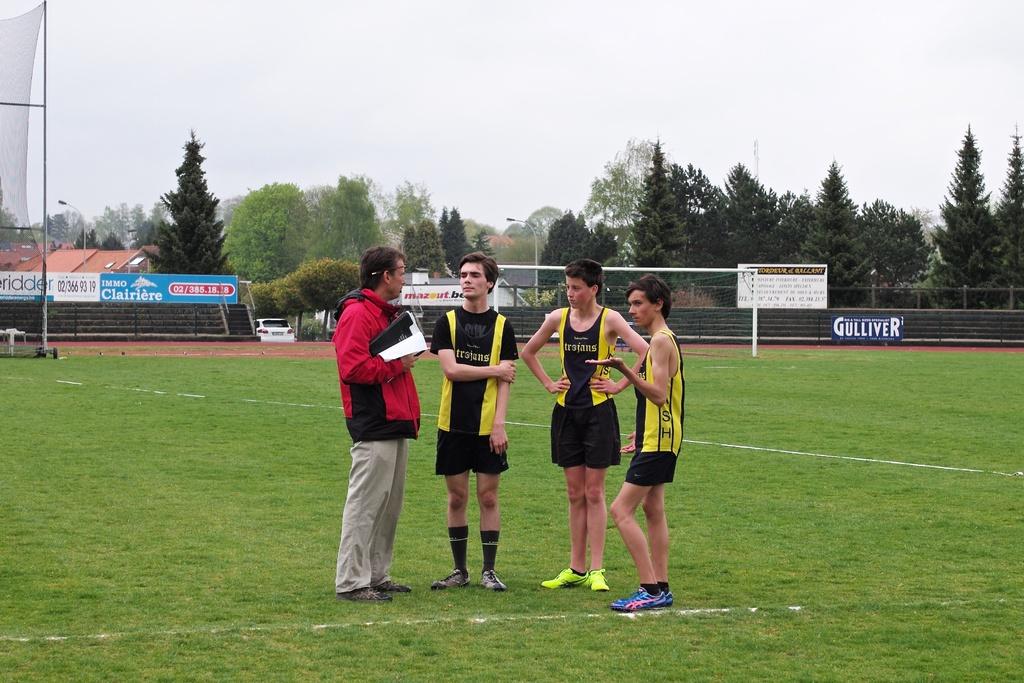What is the name of their team?
Provide a succinct answer. Trojans. What is being advertised on the back fence to the right?
Keep it short and to the point. Gulliver. 